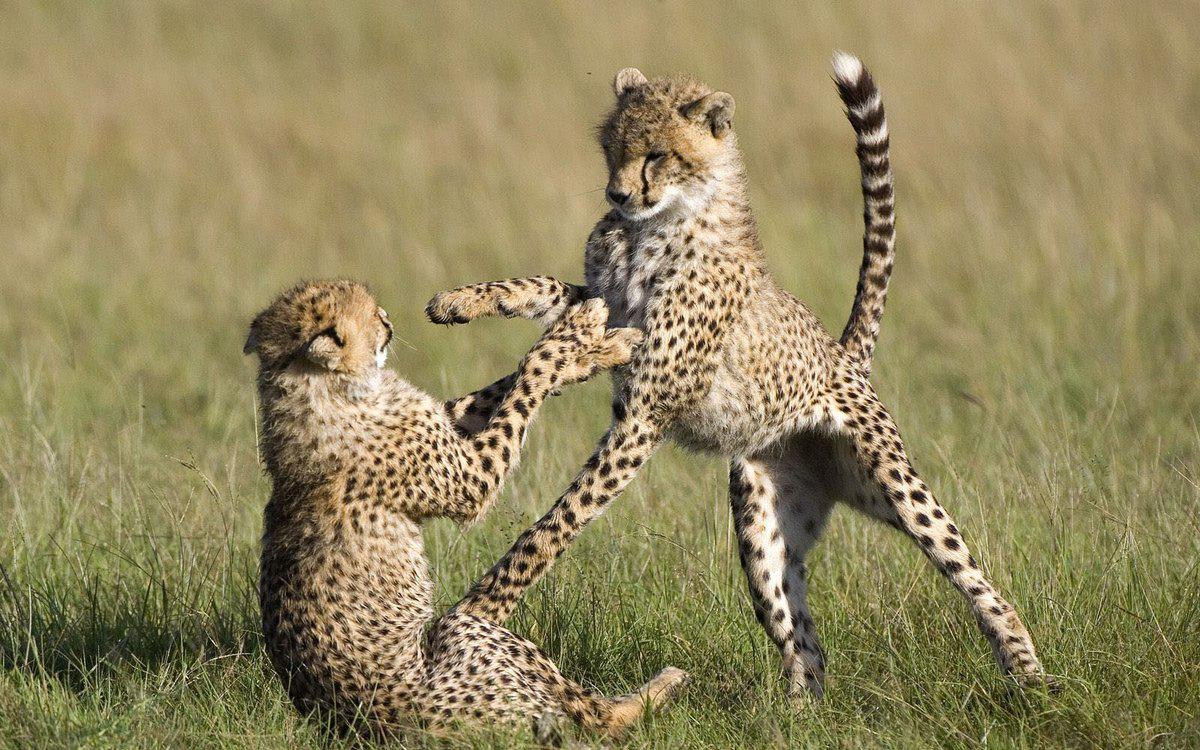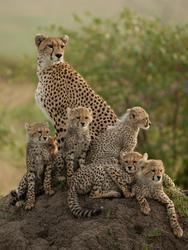The first image is the image on the left, the second image is the image on the right. Given the left and right images, does the statement "An image includes a wild spotted cat in a pouncing pose, with its tail up and both its front paws off the ground." hold true? Answer yes or no. Yes. 